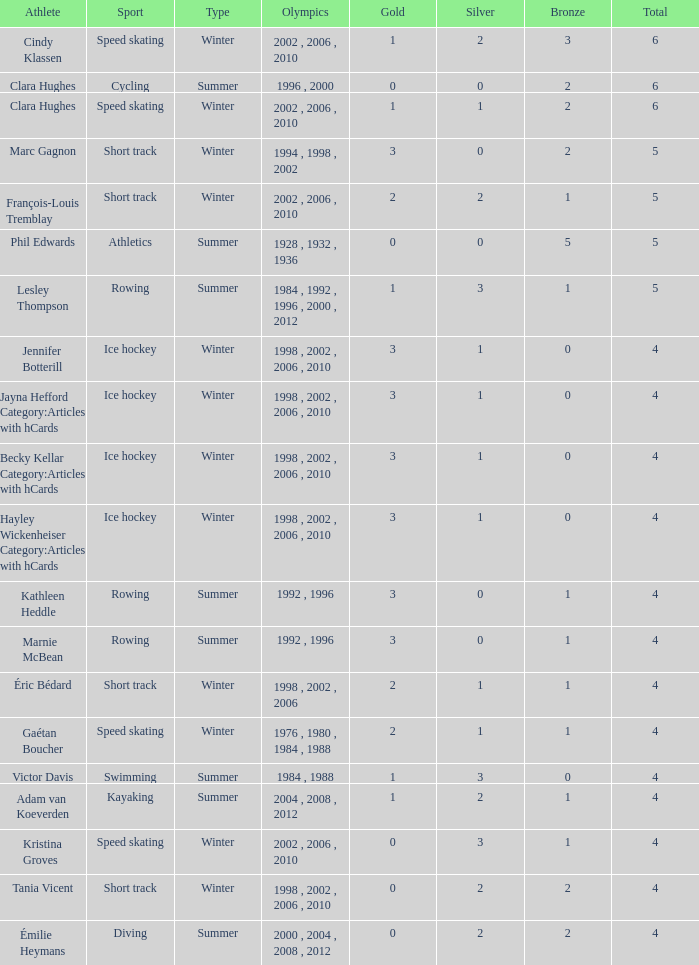What is the highest total medals winter athlete Clara Hughes has? 6.0. 